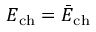<formula> <loc_0><loc_0><loc_500><loc_500>E _ { c h } = \bar { E } _ { c h }</formula> 